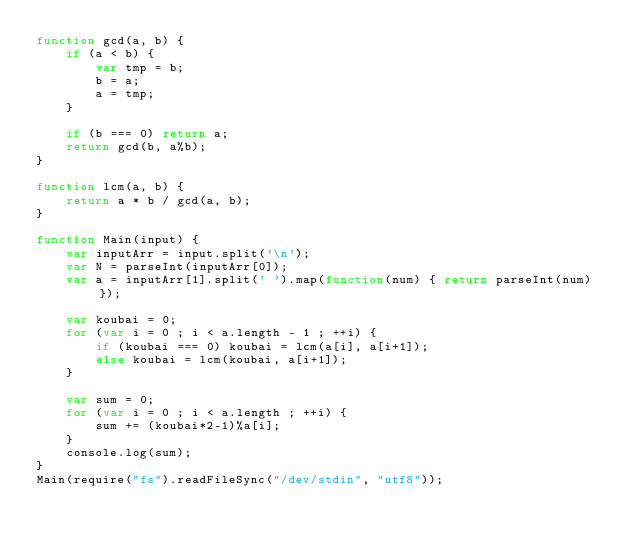<code> <loc_0><loc_0><loc_500><loc_500><_JavaScript_>function gcd(a, b) {
    if (a < b) {
        var tmp = b;
        b = a;
        a = tmp;
    }

    if (b === 0) return a;
    return gcd(b, a%b);
}

function lcm(a, b) {
    return a * b / gcd(a, b);
}

function Main(input) {
    var inputArr = input.split('\n');
    var N = parseInt(inputArr[0]);
    var a = inputArr[1].split(' ').map(function(num) { return parseInt(num) });

    var koubai = 0;
    for (var i = 0 ; i < a.length - 1 ; ++i) {
        if (koubai === 0) koubai = lcm(a[i], a[i+1]);
        else koubai = lcm(koubai, a[i+1]);
    }

    var sum = 0;
    for (var i = 0 ; i < a.length ; ++i) {
        sum += (koubai*2-1)%a[i];
    }
    console.log(sum);
}
Main(require("fs").readFileSync("/dev/stdin", "utf8"));</code> 